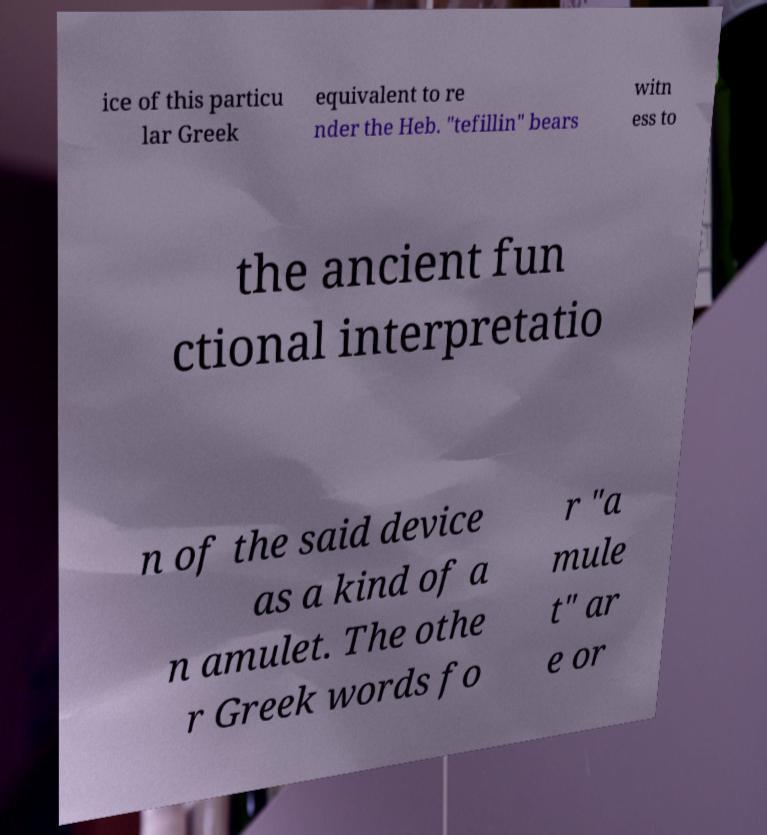Please read and relay the text visible in this image. What does it say? ice of this particu lar Greek equivalent to re nder the Heb. "tefillin" bears witn ess to the ancient fun ctional interpretatio n of the said device as a kind of a n amulet. The othe r Greek words fo r "a mule t" ar e or 